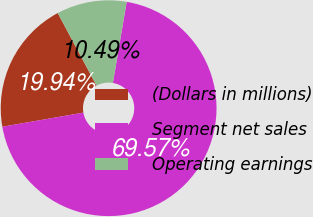Convert chart to OTSL. <chart><loc_0><loc_0><loc_500><loc_500><pie_chart><fcel>(Dollars in millions)<fcel>Segment net sales<fcel>Operating earnings<nl><fcel>19.94%<fcel>69.57%<fcel>10.49%<nl></chart> 